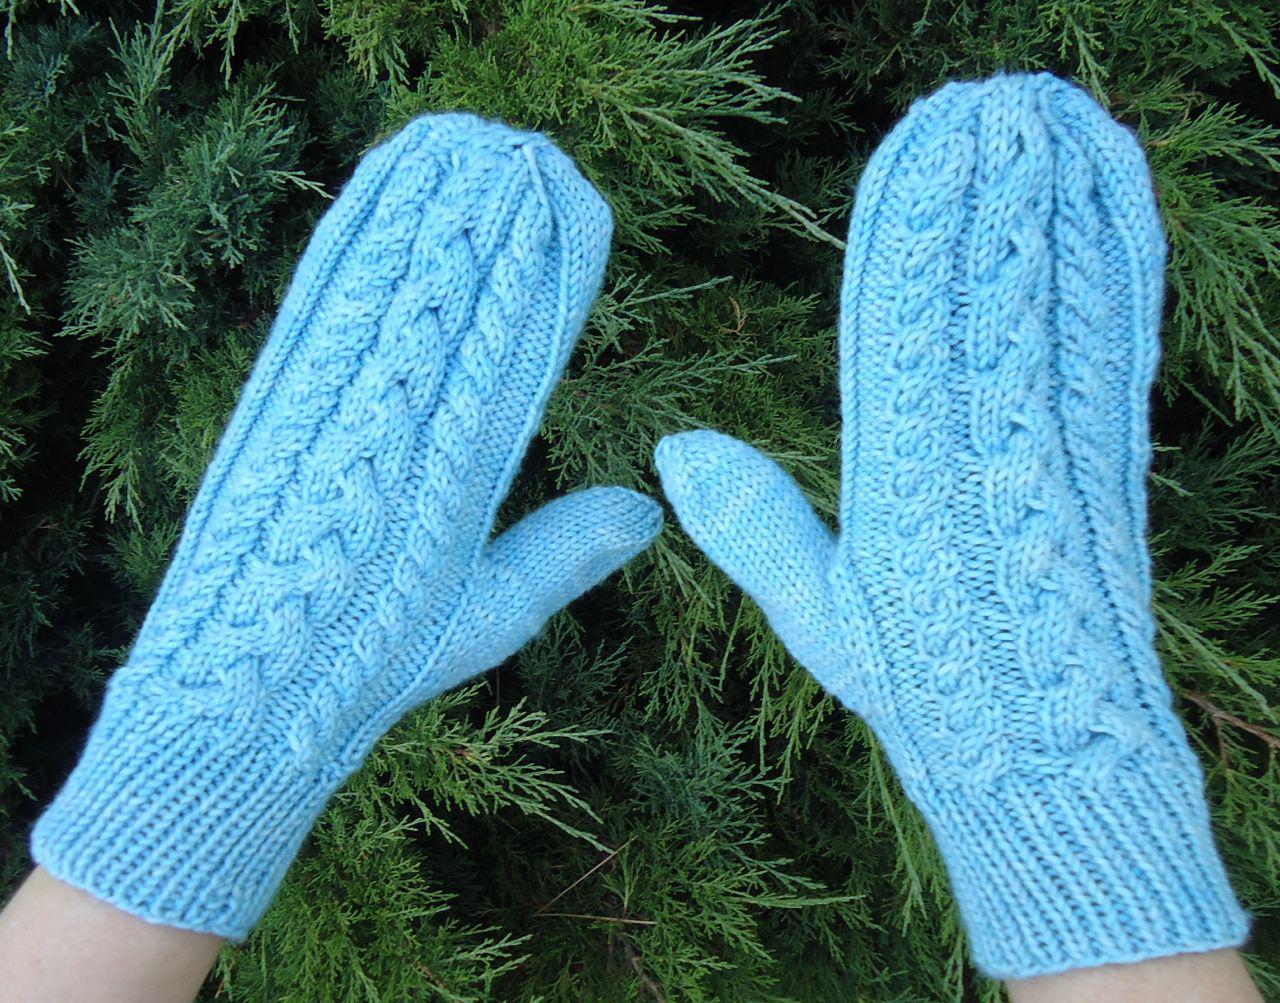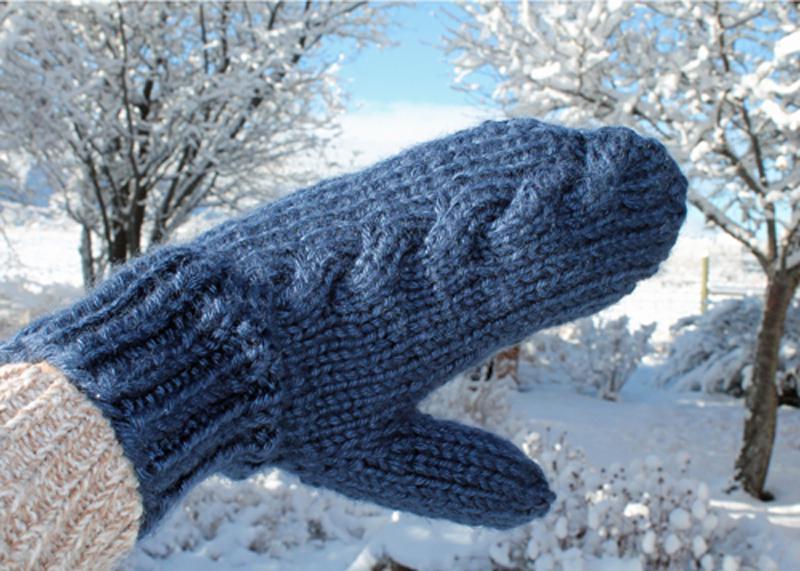The first image is the image on the left, the second image is the image on the right. For the images shown, is this caption "There are three mittens in each set of images, and they are all solid colors" true? Answer yes or no. Yes. The first image is the image on the left, the second image is the image on the right. Examine the images to the left and right. Is the description "You can see someone's eyes in every single image." accurate? Answer yes or no. No. 